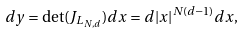Convert formula to latex. <formula><loc_0><loc_0><loc_500><loc_500>d y = \det ( J _ { L _ { N , d } } ) d x = d | x | ^ { N \left ( d - 1 \right ) } d x ,</formula> 